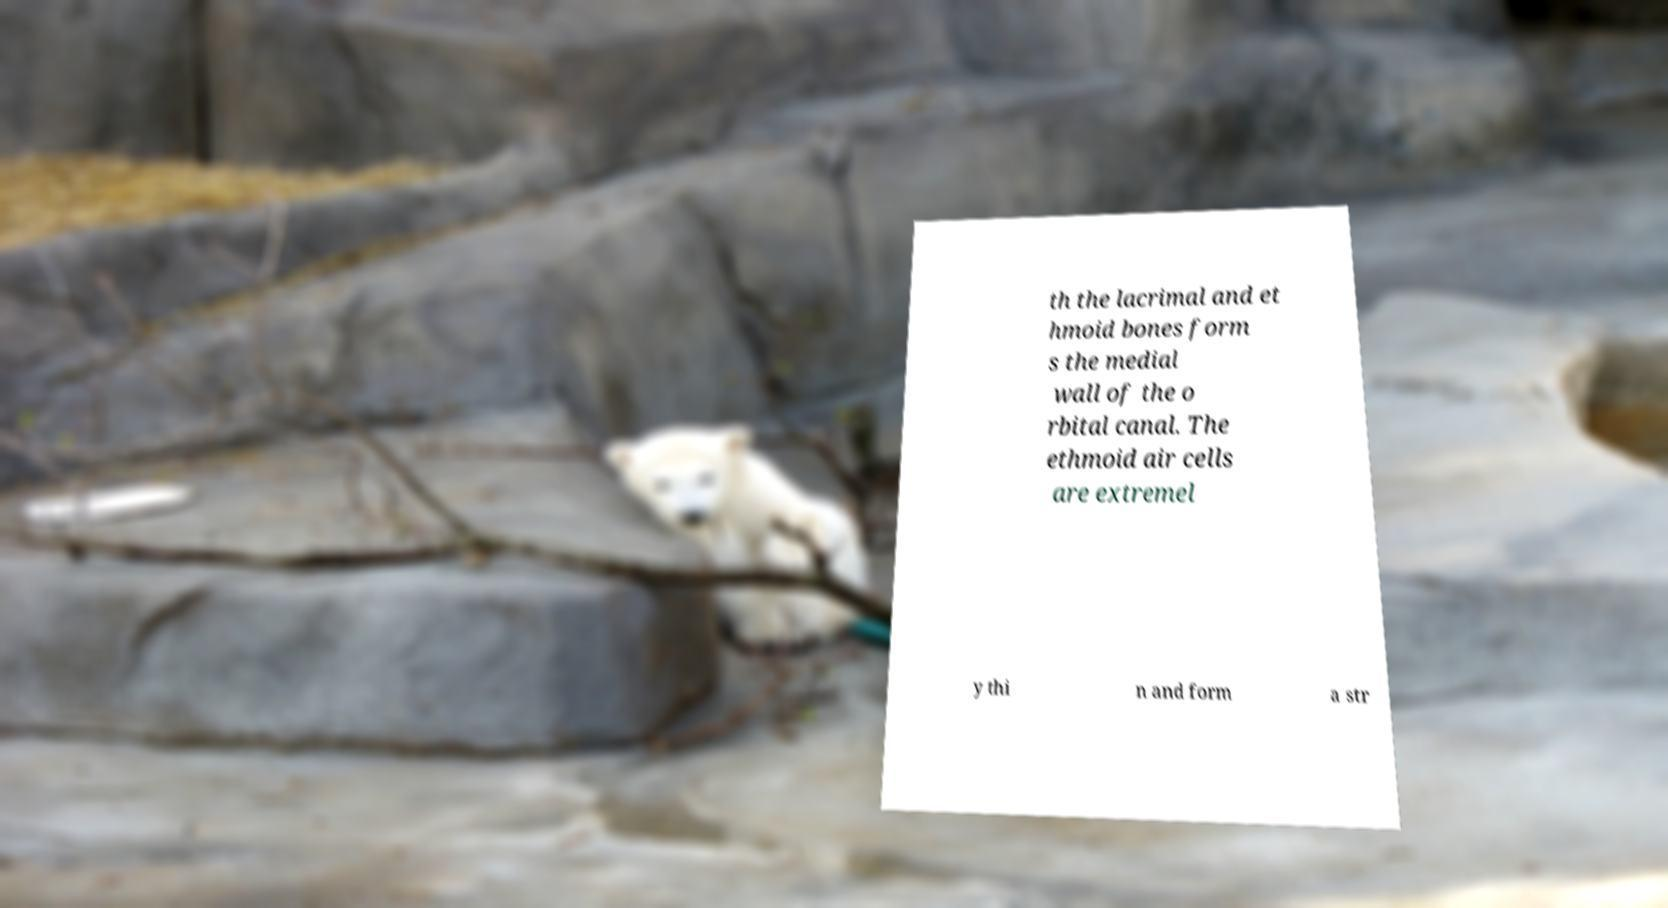Could you assist in decoding the text presented in this image and type it out clearly? th the lacrimal and et hmoid bones form s the medial wall of the o rbital canal. The ethmoid air cells are extremel y thi n and form a str 